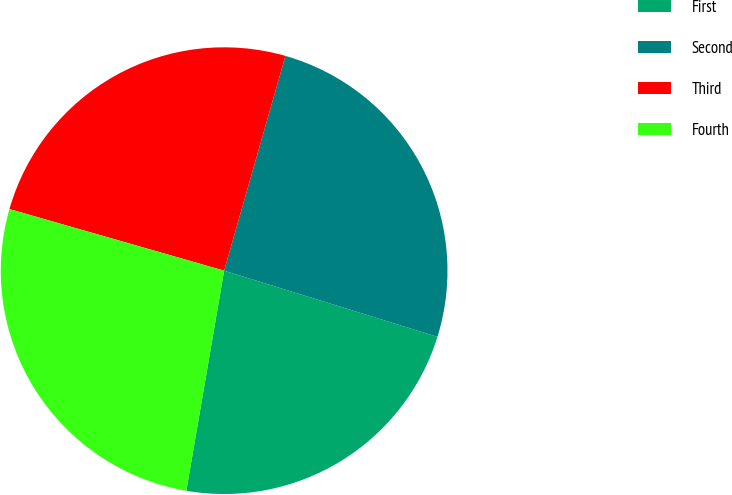Convert chart. <chart><loc_0><loc_0><loc_500><loc_500><pie_chart><fcel>First<fcel>Second<fcel>Third<fcel>Fourth<nl><fcel>22.92%<fcel>25.36%<fcel>24.98%<fcel>26.74%<nl></chart> 